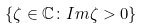Convert formula to latex. <formula><loc_0><loc_0><loc_500><loc_500>\{ \zeta \in \mathbb { C } \colon I m \zeta > 0 \}</formula> 